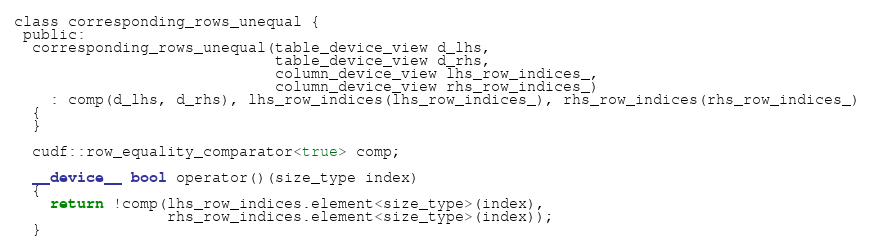<code> <loc_0><loc_0><loc_500><loc_500><_Cuda_>class corresponding_rows_unequal {
 public:
  corresponding_rows_unequal(table_device_view d_lhs,
                             table_device_view d_rhs,
                             column_device_view lhs_row_indices_,
                             column_device_view rhs_row_indices_)
    : comp(d_lhs, d_rhs), lhs_row_indices(lhs_row_indices_), rhs_row_indices(rhs_row_indices_)
  {
  }

  cudf::row_equality_comparator<true> comp;

  __device__ bool operator()(size_type index)
  {
    return !comp(lhs_row_indices.element<size_type>(index),
                 rhs_row_indices.element<size_type>(index));
  }
</code> 